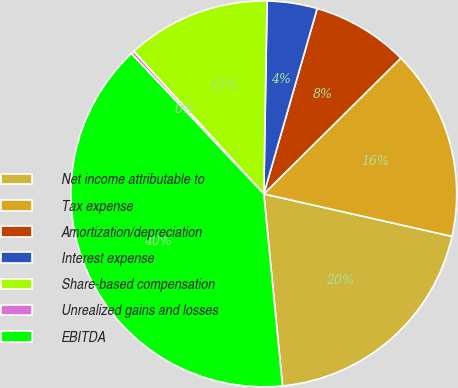Convert chart. <chart><loc_0><loc_0><loc_500><loc_500><pie_chart><fcel>Net income attributable to<fcel>Tax expense<fcel>Amortization/depreciation<fcel>Interest expense<fcel>Share-based compensation<fcel>Unrealized gains and losses<fcel>EBITDA<nl><fcel>19.92%<fcel>15.96%<fcel>8.11%<fcel>4.19%<fcel>12.04%<fcel>0.27%<fcel>39.51%<nl></chart> 